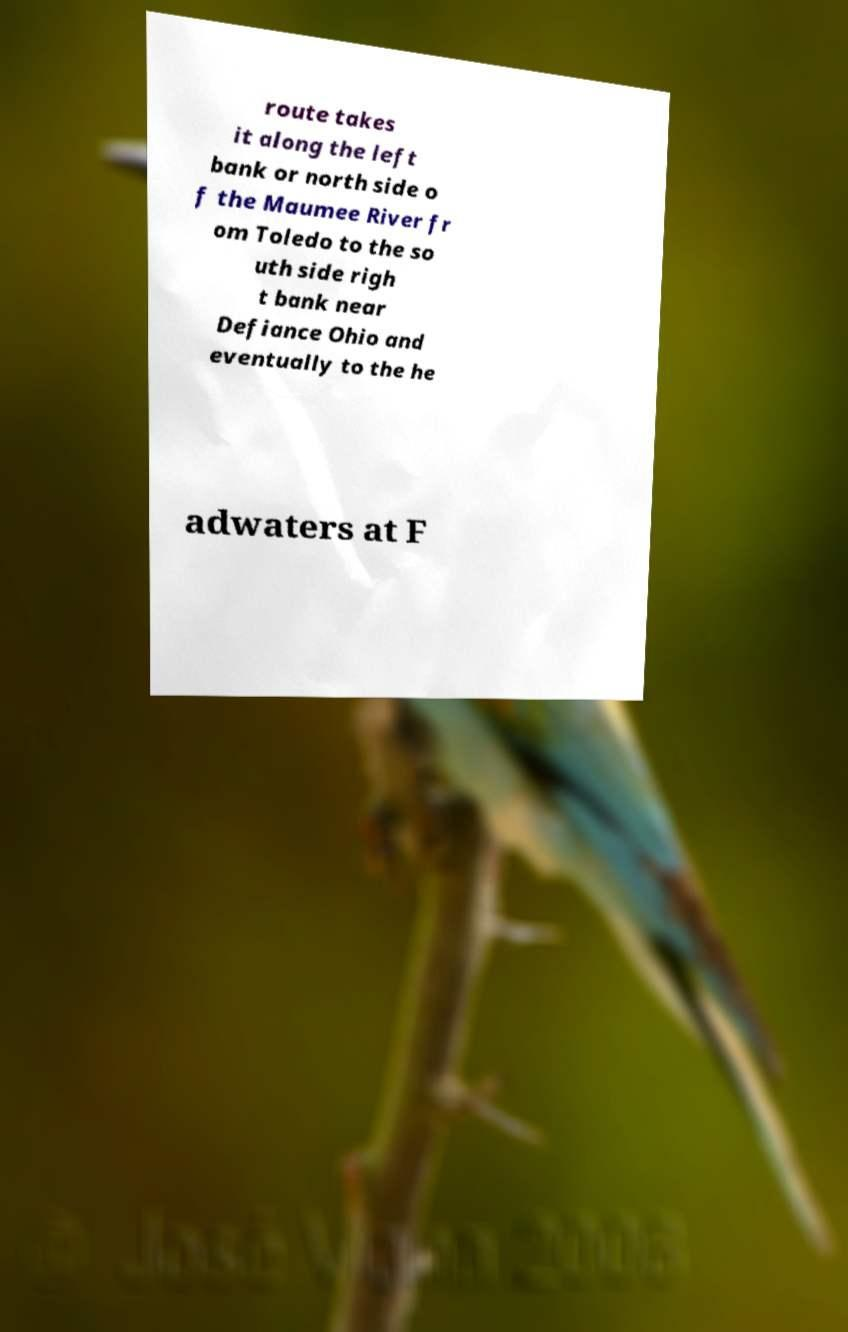Can you read and provide the text displayed in the image?This photo seems to have some interesting text. Can you extract and type it out for me? route takes it along the left bank or north side o f the Maumee River fr om Toledo to the so uth side righ t bank near Defiance Ohio and eventually to the he adwaters at F 